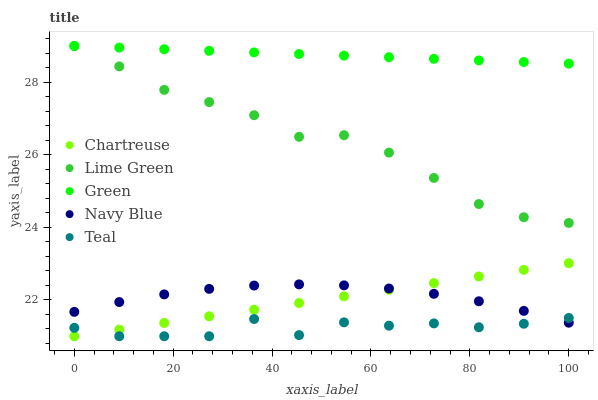Does Teal have the minimum area under the curve?
Answer yes or no. Yes. Does Green have the maximum area under the curve?
Answer yes or no. Yes. Does Chartreuse have the minimum area under the curve?
Answer yes or no. No. Does Chartreuse have the maximum area under the curve?
Answer yes or no. No. Is Green the smoothest?
Answer yes or no. Yes. Is Teal the roughest?
Answer yes or no. Yes. Is Chartreuse the smoothest?
Answer yes or no. No. Is Chartreuse the roughest?
Answer yes or no. No. Does Chartreuse have the lowest value?
Answer yes or no. Yes. Does Lime Green have the lowest value?
Answer yes or no. No. Does Lime Green have the highest value?
Answer yes or no. Yes. Does Chartreuse have the highest value?
Answer yes or no. No. Is Navy Blue less than Green?
Answer yes or no. Yes. Is Lime Green greater than Navy Blue?
Answer yes or no. Yes. Does Teal intersect Navy Blue?
Answer yes or no. Yes. Is Teal less than Navy Blue?
Answer yes or no. No. Is Teal greater than Navy Blue?
Answer yes or no. No. Does Navy Blue intersect Green?
Answer yes or no. No. 